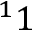<formula> <loc_0><loc_0><loc_500><loc_500>^ { 1 } 1</formula> 